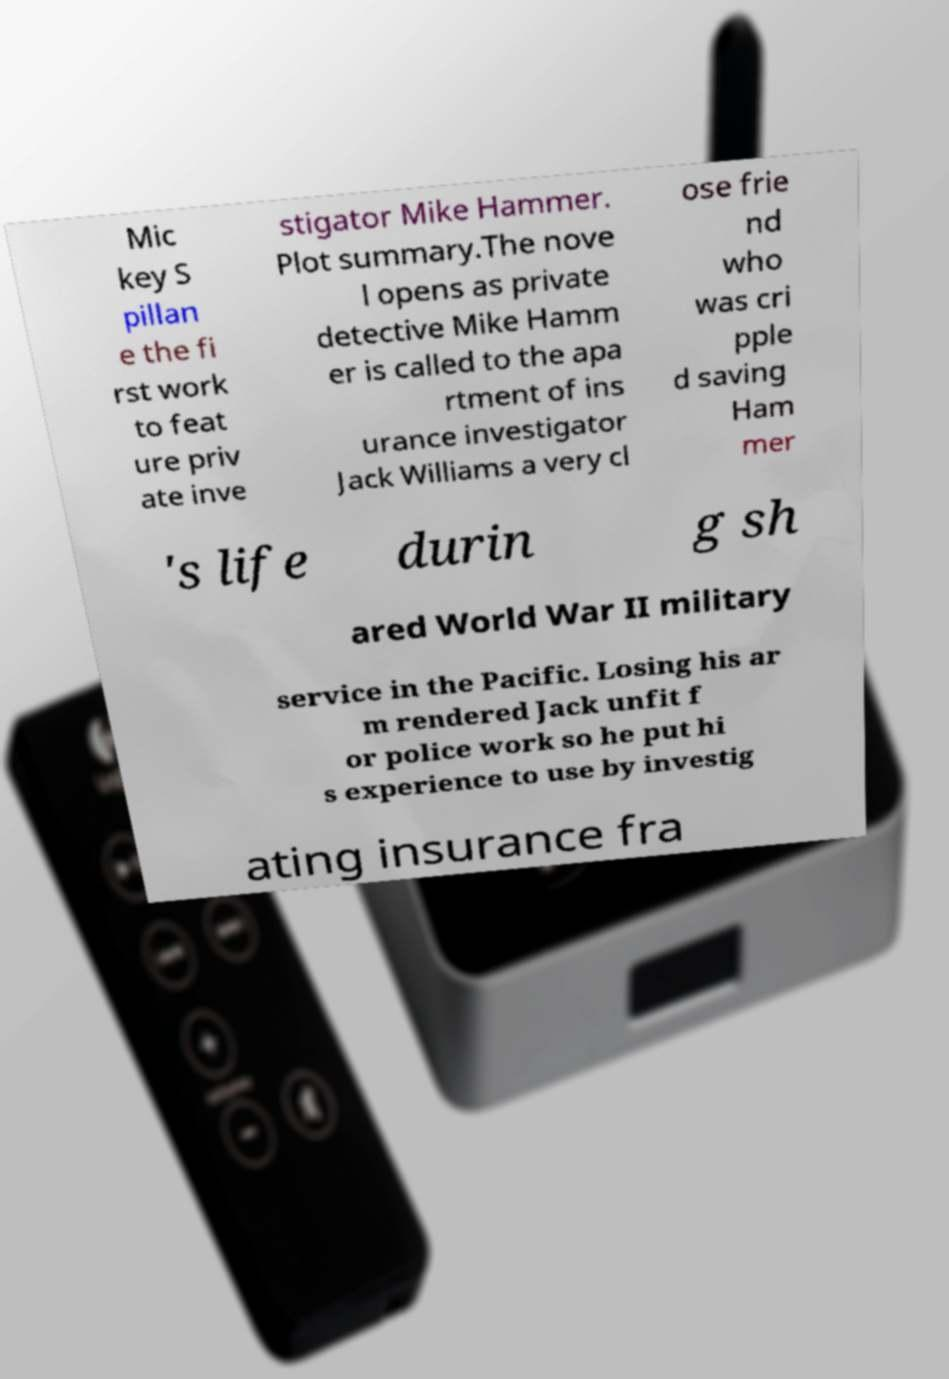What messages or text are displayed in this image? I need them in a readable, typed format. Mic key S pillan e the fi rst work to feat ure priv ate inve stigator Mike Hammer. Plot summary.The nove l opens as private detective Mike Hamm er is called to the apa rtment of ins urance investigator Jack Williams a very cl ose frie nd who was cri pple d saving Ham mer 's life durin g sh ared World War II military service in the Pacific. Losing his ar m rendered Jack unfit f or police work so he put hi s experience to use by investig ating insurance fra 